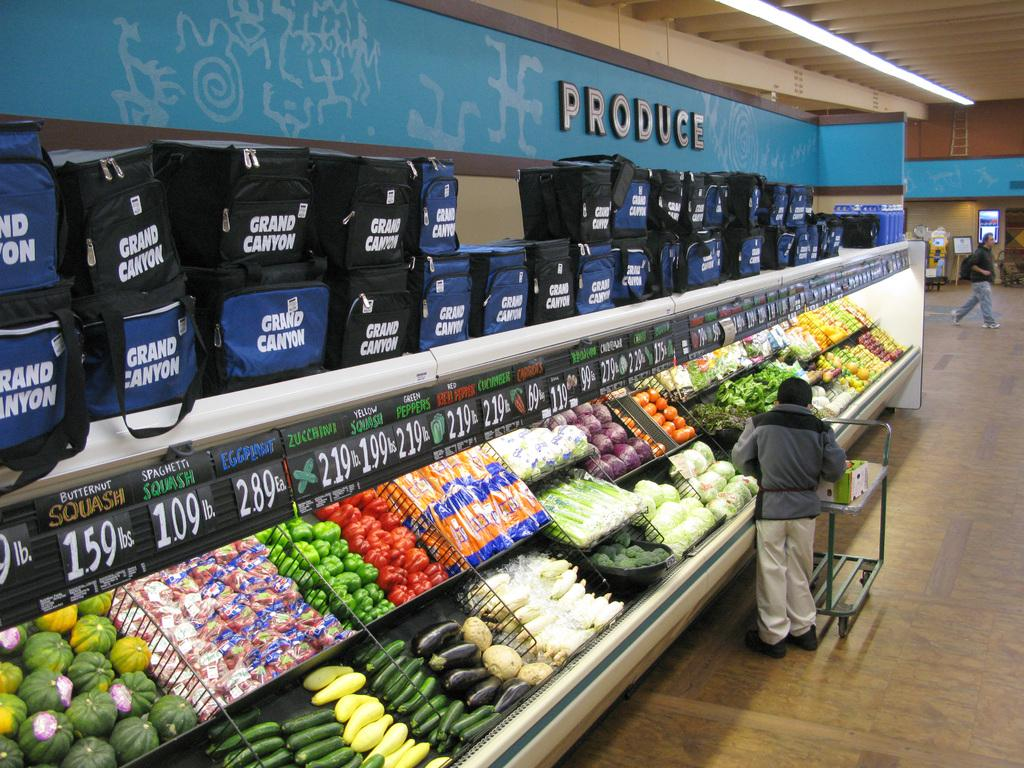<image>
Share a concise interpretation of the image provided. the produce section of a grocery store with a man in front of it 